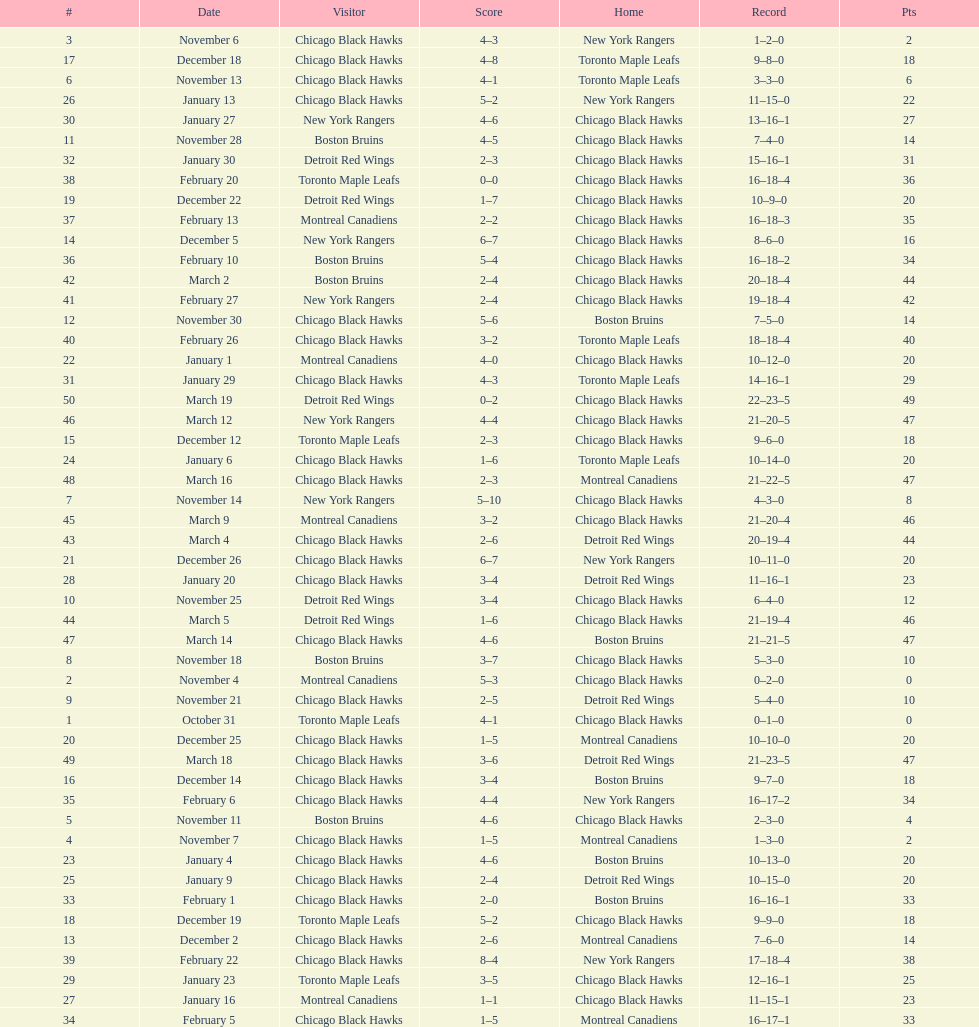What is the difference in pts between december 5th and november 11th? 3. 